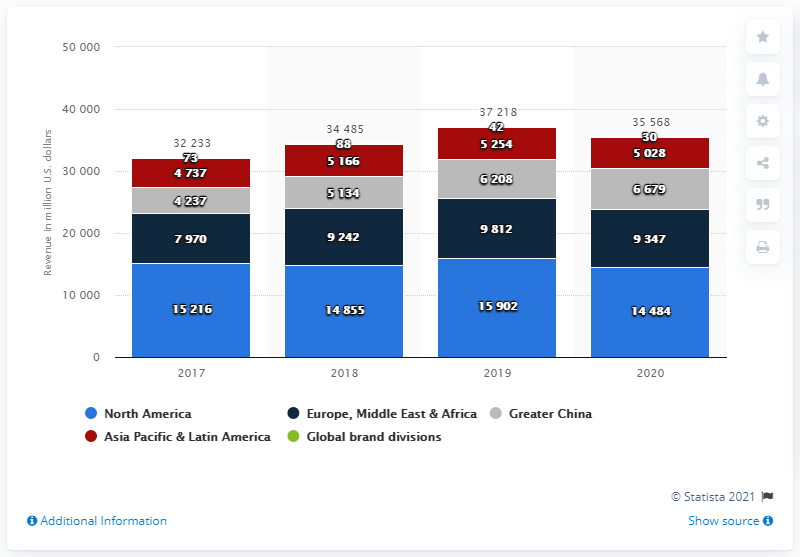Outline some significant characteristics in this image. Nike's North American revenue in 2020 was 14,484 million dollars. 